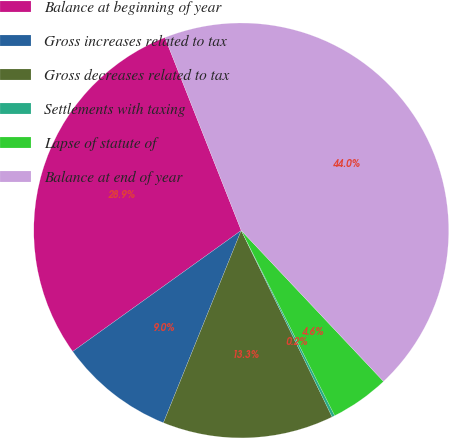Convert chart to OTSL. <chart><loc_0><loc_0><loc_500><loc_500><pie_chart><fcel>Balance at beginning of year<fcel>Gross increases related to tax<fcel>Gross decreases related to tax<fcel>Settlements with taxing<fcel>Lapse of statute of<fcel>Balance at end of year<nl><fcel>28.92%<fcel>8.97%<fcel>13.34%<fcel>0.22%<fcel>4.59%<fcel>43.97%<nl></chart> 